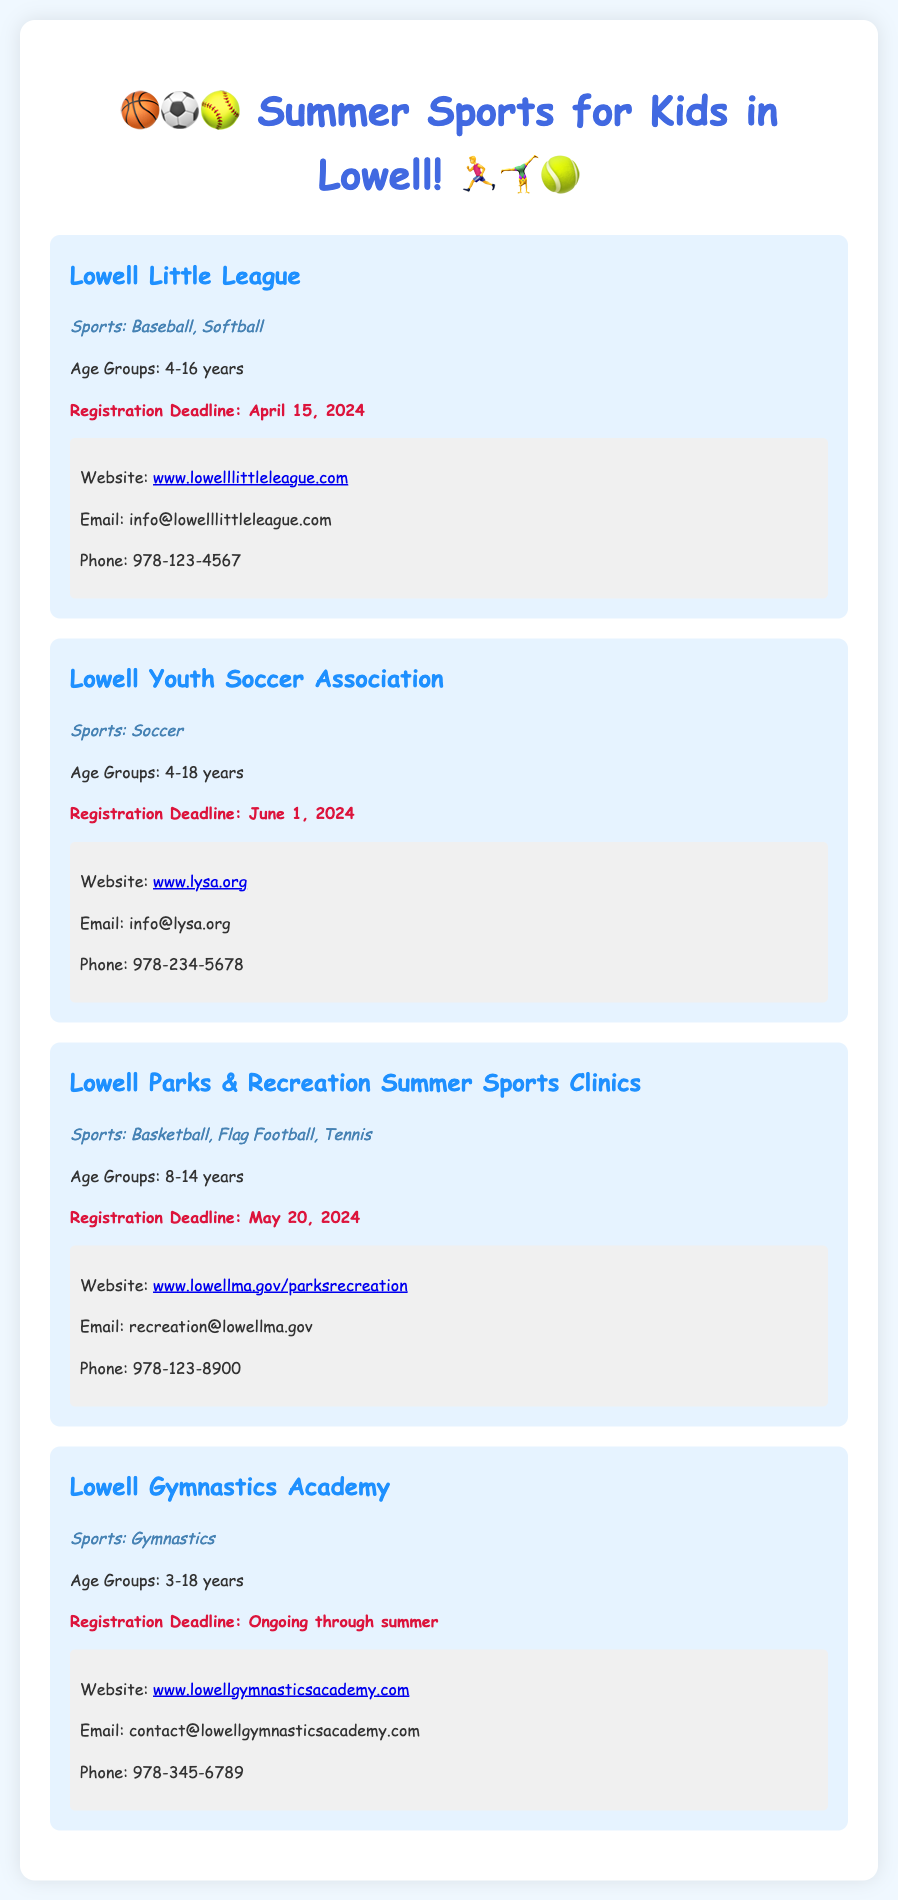What is the registration deadline for Lowell Little League? The registration deadline for Lowell Little League is mentioned in the document as April 15, 2024.
Answer: April 15, 2024 What sports are offered by Lowell Parks & Recreation Summer Sports Clinics? The document lists Basketball, Flag Football, and Tennis as the sports offered by Lowell Parks & Recreation Summer Sports Clinics.
Answer: Basketball, Flag Football, Tennis What age group can participate in the Lowell Youth Soccer Association? The document specifies that the age group for the Lowell Youth Soccer Association is 4-18 years.
Answer: 4-18 years Which organization has an ongoing registration process? The Lowell Gymnastics Academy is mentioned to have an ongoing registration process throughout the summer.
Answer: Lowell Gymnastics Academy What is the website for the Lowell Parks & Recreation? The document provides the website for Lowell Parks & Recreation as www.lowellma.gov/parksrecreation.
Answer: www.lowellma.gov/parksrecreation Which league offers sports for the youngest age group of 3 years? Lowell Gymnastics Academy offers sports for the youngest age group starting at 3 years old according to the document.
Answer: Lowell Gymnastics Academy What is the contact email for Lowell Youth Soccer Association? The document states the contact email for Lowell Youth Soccer Association is info@lysa.org.
Answer: info@lysa.org What age group does Lowell Little League cater to? The document indicates that Lowell Little League caters to age groups from 4 to 16 years.
Answer: 4-16 years 